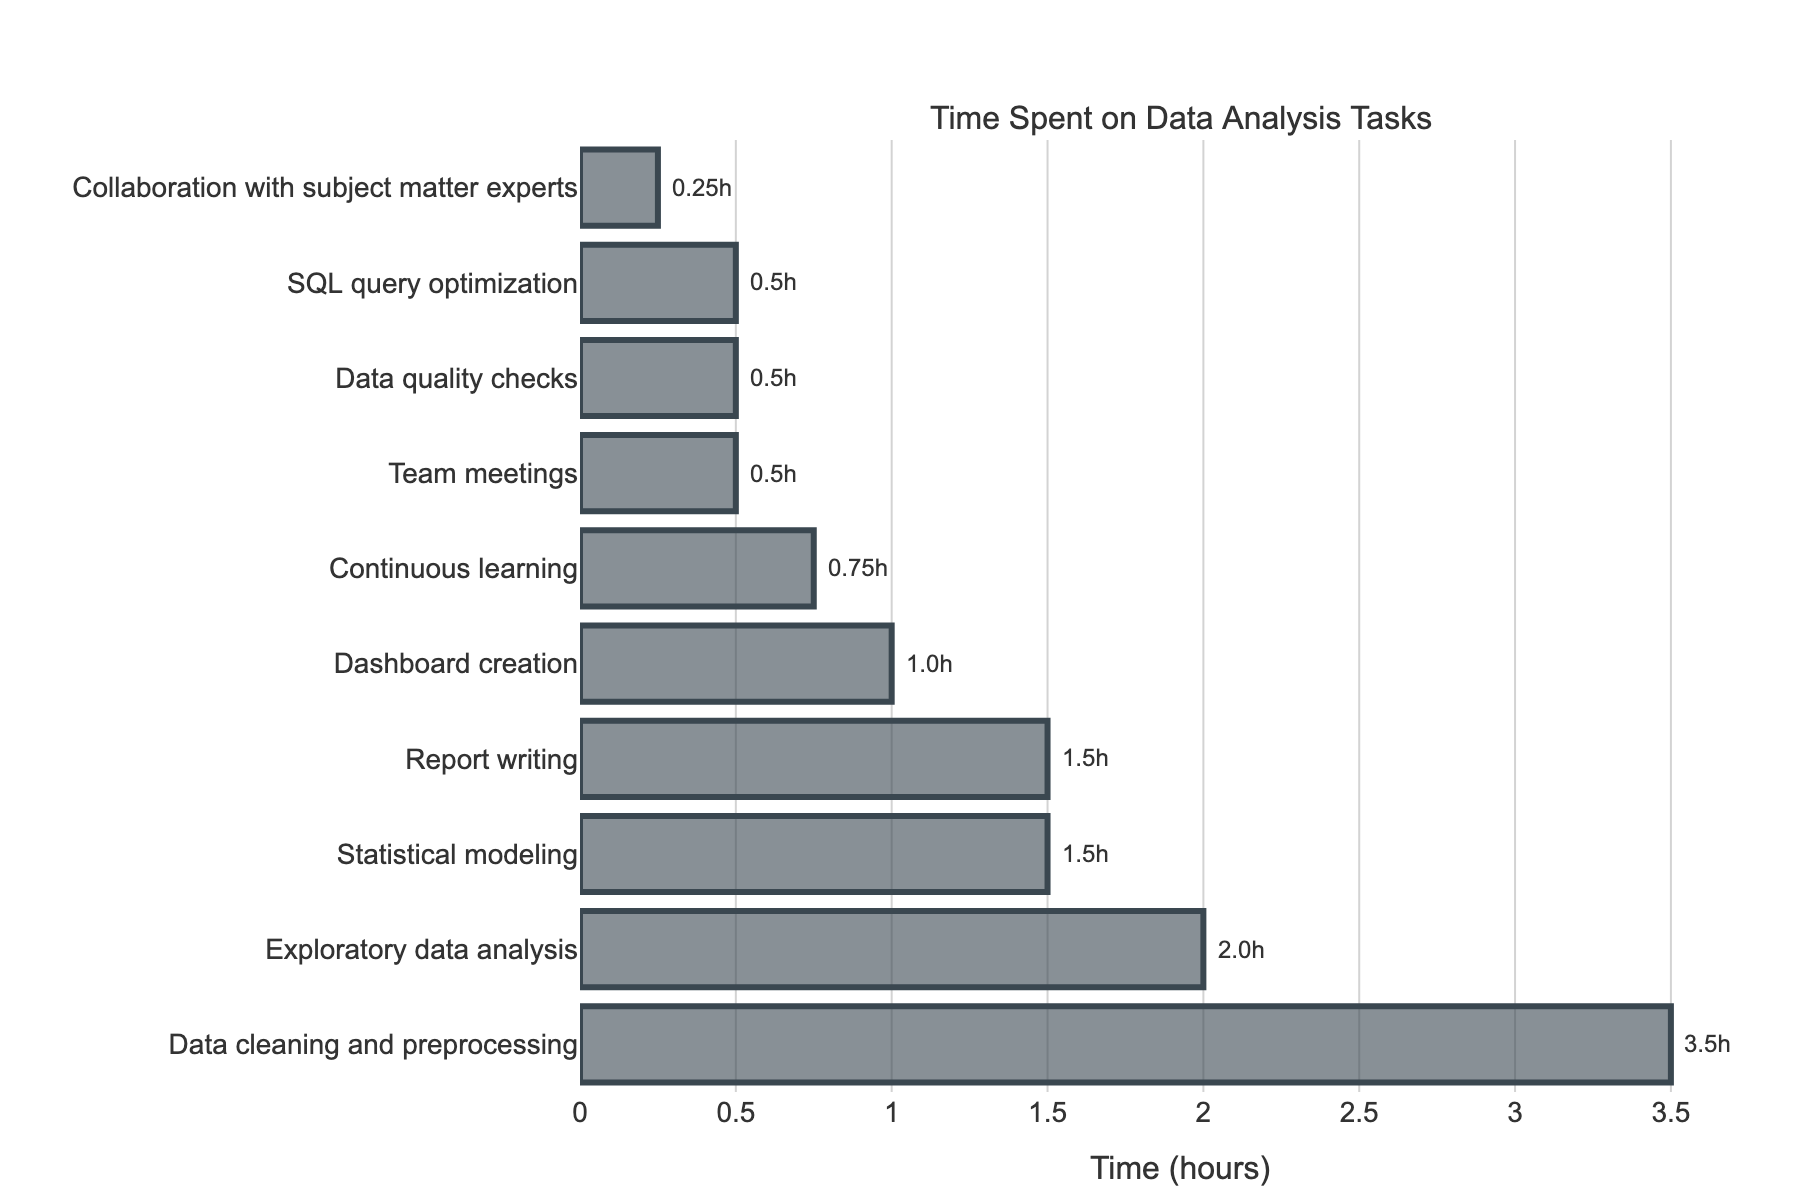How much time is spent on Data cleaning and preprocessing compared to Exploratory data analysis? Data cleaning and preprocessing takes 3.5 hours, while Exploratory data analysis takes 2.0 hours. Therefore, Data cleaning and preprocessing takes 3.5 - 2.0 = 1.5 hours more than Exploratory data analysis.
Answer: 1.5 hours What are the top three tasks that occupy the most time? By looking at the lengths of the bars, the top three tasks with the longest bars, indicating the most time spent, are Data cleaning and preprocessing (3.5 hours), Exploratory data analysis (2.0 hours), and both Statistical modeling and Report writing (1.5 hours each).
Answer: Data cleaning and preprocessing, Exploratory data analysis, Statistical modeling, and Report writing What is the total time spent on data quality checks, SQL query optimization, and collaboration with subject matter experts? Sum the time spent on Data quality checks (0.5 hours), SQL query optimization (0.5 hours), and Collaboration with subject matter experts (0.25 hours): 0.5 + 0.5 + 0.25 = 1.25 hours.
Answer: 1.25 hours Does Dashboard creation take more or less time than Continuous learning? Dashboard creation takes 1.0 hour, while Continuous learning takes 0.75 hours. Therefore, Dashboard creation takes more time than Continuous learning.
Answer: More Which task takes the least amount of time, and how much time is it? The shortest bar on the chart represents Collaboration with subject matter experts, which takes 0.25 hours.
Answer: Collaboration with subject matter experts, 0.25 hours 